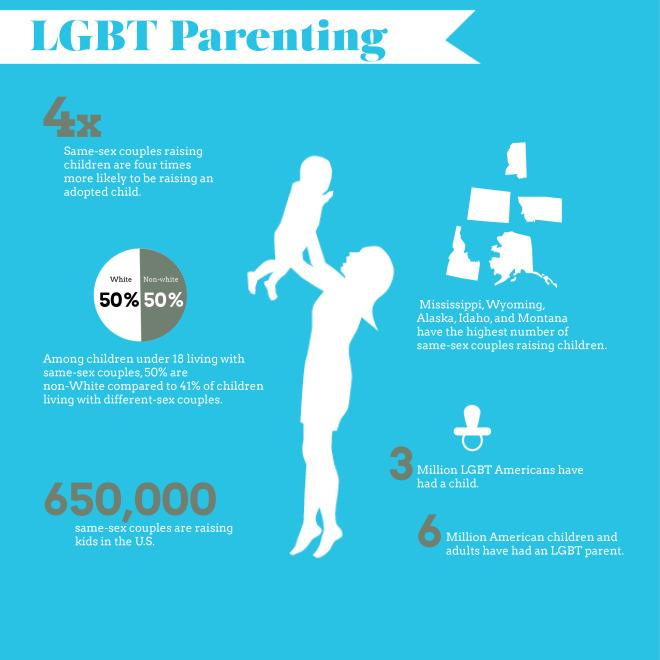List a handful of essential elements in this visual. The population of LGBT Americans who have a child is approximately 3 million. There are approximately 650,000 same-sex couples in the United States who are raising children. According to estimates, approximately 6 million American children and adults have LGBT parents. Among children under 18 living with same-sex couples, 50% of them are white. 